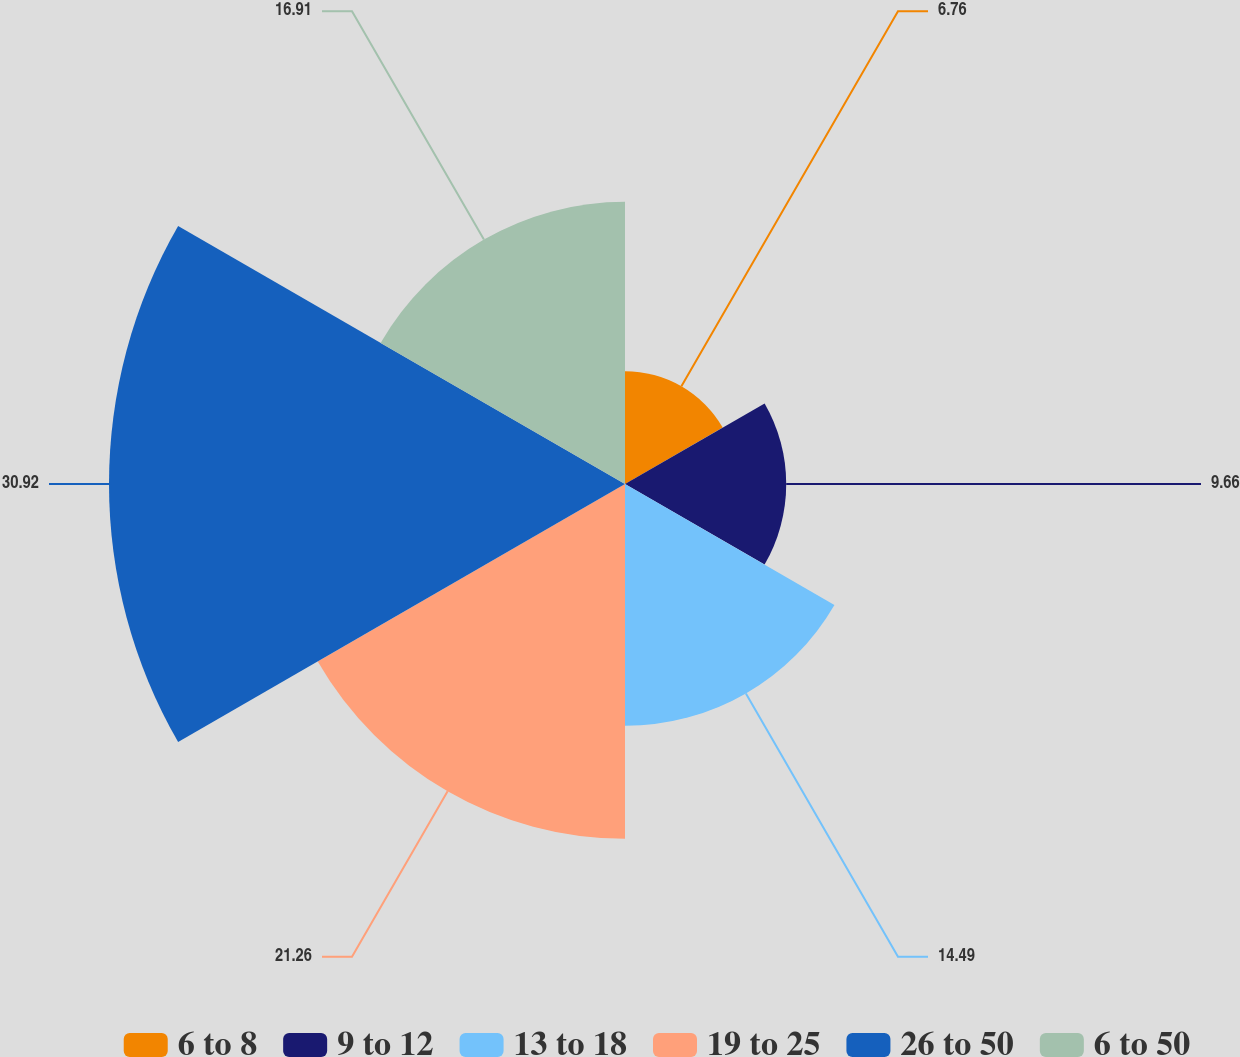<chart> <loc_0><loc_0><loc_500><loc_500><pie_chart><fcel>6 to 8<fcel>9 to 12<fcel>13 to 18<fcel>19 to 25<fcel>26 to 50<fcel>6 to 50<nl><fcel>6.76%<fcel>9.66%<fcel>14.49%<fcel>21.26%<fcel>30.92%<fcel>16.91%<nl></chart> 